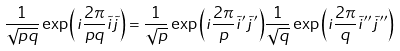Convert formula to latex. <formula><loc_0><loc_0><loc_500><loc_500>\frac { 1 } { \sqrt { p q } } \exp { \left ( { i } \frac { 2 \pi } { p q } \tilde { i } \tilde { j } \right ) } = \frac { 1 } { \sqrt { p } } \exp { \left ( { i } \frac { 2 \pi } { p } \tilde { i } ^ { \prime } \tilde { j } ^ { \prime } \right ) } \frac { 1 } { \sqrt { q } } \exp { \left ( { i } \frac { 2 \pi } { q } \tilde { i } ^ { \prime \prime } \tilde { j } ^ { \prime \prime } \right ) }</formula> 